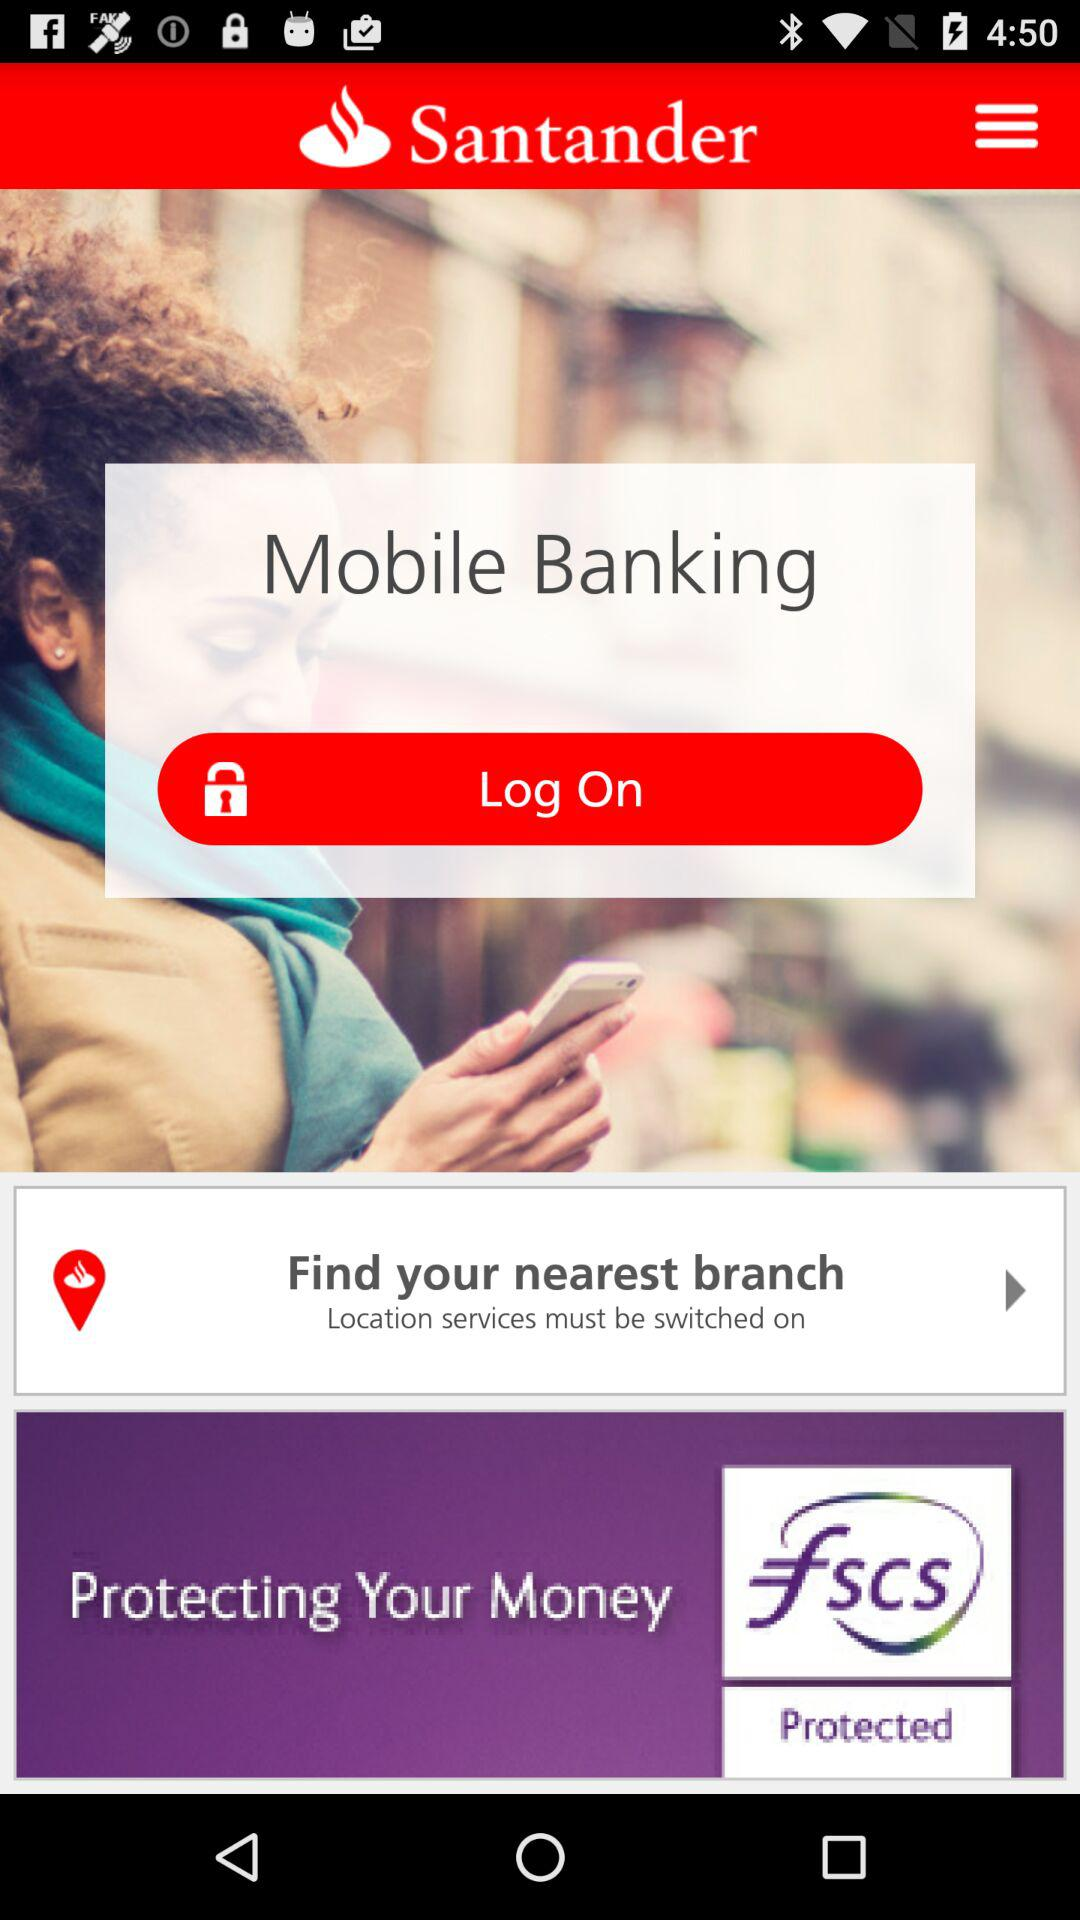What is the application name? The application name is "Santander". 